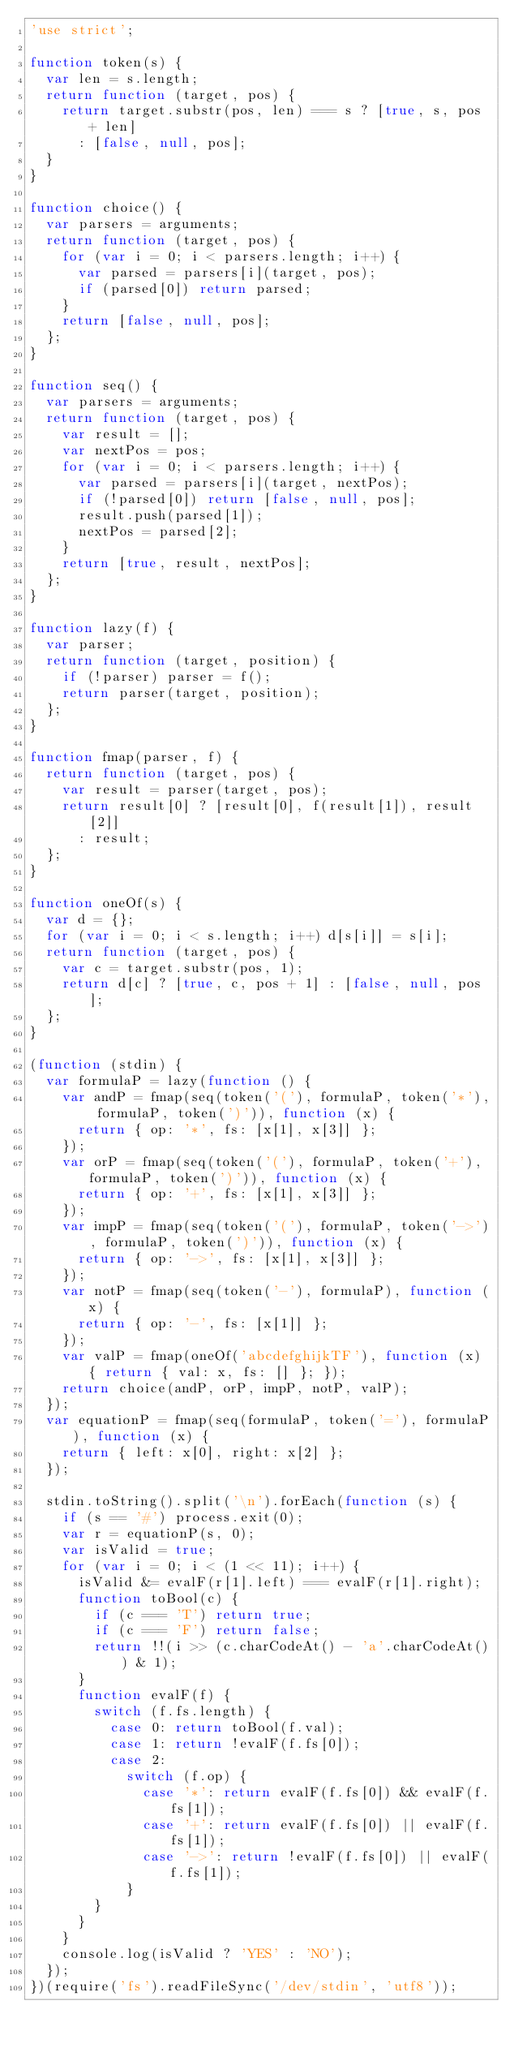Convert code to text. <code><loc_0><loc_0><loc_500><loc_500><_JavaScript_>'use strict';

function token(s) {
  var len = s.length;
  return function (target, pos) {
    return target.substr(pos, len) === s ? [true, s, pos + len]
      : [false, null, pos];
  }
}

function choice() {
  var parsers = arguments;
  return function (target, pos) {
    for (var i = 0; i < parsers.length; i++) {
      var parsed = parsers[i](target, pos);
      if (parsed[0]) return parsed;
    }
    return [false, null, pos];
  };
}

function seq() {
  var parsers = arguments;
  return function (target, pos) {
    var result = [];
    var nextPos = pos;
    for (var i = 0; i < parsers.length; i++) {
      var parsed = parsers[i](target, nextPos);
      if (!parsed[0]) return [false, null, pos];
      result.push(parsed[1]);
      nextPos = parsed[2];
    }
    return [true, result, nextPos];
  };
}

function lazy(f) {
  var parser;
  return function (target, position) {
    if (!parser) parser = f();
    return parser(target, position);
  };
}

function fmap(parser, f) {
  return function (target, pos) {
    var result = parser(target, pos);
    return result[0] ? [result[0], f(result[1]), result[2]]
      : result;
  };
}

function oneOf(s) {
  var d = {};
  for (var i = 0; i < s.length; i++) d[s[i]] = s[i];
  return function (target, pos) {
    var c = target.substr(pos, 1);
    return d[c] ? [true, c, pos + 1] : [false, null, pos];
  };
}

(function (stdin) {
  var formulaP = lazy(function () {
    var andP = fmap(seq(token('('), formulaP, token('*'), formulaP, token(')')), function (x) {
      return { op: '*', fs: [x[1], x[3]] };
    });
    var orP = fmap(seq(token('('), formulaP, token('+'), formulaP, token(')')), function (x) {
      return { op: '+', fs: [x[1], x[3]] };
    });
    var impP = fmap(seq(token('('), formulaP, token('->'), formulaP, token(')')), function (x) {
      return { op: '->', fs: [x[1], x[3]] };
    });
    var notP = fmap(seq(token('-'), formulaP), function (x) {
      return { op: '-', fs: [x[1]] };
    });
    var valP = fmap(oneOf('abcdefghijkTF'), function (x) { return { val: x, fs: [] }; });
    return choice(andP, orP, impP, notP, valP);
  });
  var equationP = fmap(seq(formulaP, token('='), formulaP), function (x) {
    return { left: x[0], right: x[2] };
  });

  stdin.toString().split('\n').forEach(function (s) {
    if (s == '#') process.exit(0);
    var r = equationP(s, 0);
    var isValid = true;
    for (var i = 0; i < (1 << 11); i++) {
      isValid &= evalF(r[1].left) === evalF(r[1].right);
      function toBool(c) {
        if (c === 'T') return true;
        if (c === 'F') return false;
        return !!(i >> (c.charCodeAt() - 'a'.charCodeAt()) & 1);
      }
      function evalF(f) {
        switch (f.fs.length) {
          case 0: return toBool(f.val);
          case 1: return !evalF(f.fs[0]);
          case 2:
            switch (f.op) {
              case '*': return evalF(f.fs[0]) && evalF(f.fs[1]);
              case '+': return evalF(f.fs[0]) || evalF(f.fs[1]);
              case '->': return !evalF(f.fs[0]) || evalF(f.fs[1]);
            }
        }
      }
    }
    console.log(isValid ? 'YES' : 'NO');
  });
})(require('fs').readFileSync('/dev/stdin', 'utf8'));</code> 